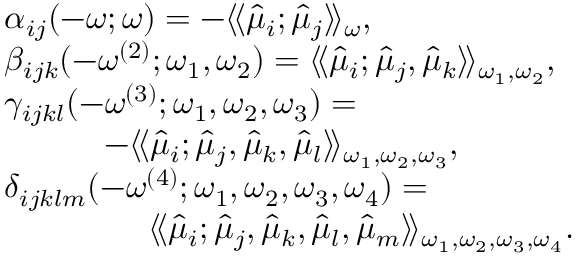Convert formula to latex. <formula><loc_0><loc_0><loc_500><loc_500>\begin{array} { r l } & { \alpha _ { i j } ( - \omega ; \omega ) = - \langle \, \langle \hat { \mu } _ { i } ; \hat { \mu } _ { j } \rangle \, \rangle _ { \omega } , } \\ & { \beta _ { i j k } ( - \omega ^ { ( 2 ) } ; \omega _ { 1 } , \omega _ { 2 } ) = \langle \, \langle \hat { \mu } _ { i } ; \hat { \mu } _ { j } , \hat { \mu } _ { k } \rangle \, \rangle _ { \omega _ { 1 } , \omega _ { 2 } } , } \\ & { \gamma _ { i j k l } ( - \omega ^ { ( 3 ) } ; \omega _ { 1 } , \omega _ { 2 } , \omega _ { 3 } ) = } \\ & { \quad - \langle \, \langle \hat { \mu } _ { i } ; \hat { \mu } _ { j } , \hat { \mu } _ { k } , \hat { \mu } _ { l } \rangle \, \rangle _ { \omega _ { 1 } , \omega _ { 2 } , \omega _ { 3 } } , } \\ & { \delta _ { i j k l m } ( - \omega ^ { ( 4 ) } ; \omega _ { 1 } , \omega _ { 2 } , \omega _ { 3 } , \omega _ { 4 } ) = } \\ & { \quad \ \langle \, \langle \hat { \mu } _ { i } ; \hat { \mu } _ { j } , \hat { \mu } _ { k } , \hat { \mu } _ { l } , \hat { \mu } _ { m } \rangle \, \rangle _ { \omega _ { 1 } , \omega _ { 2 } , \omega _ { 3 } , \omega _ { 4 } } . } \end{array}</formula> 